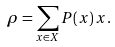<formula> <loc_0><loc_0><loc_500><loc_500>\rho & = \sum _ { x \in X } P ( x ) \, x .</formula> 